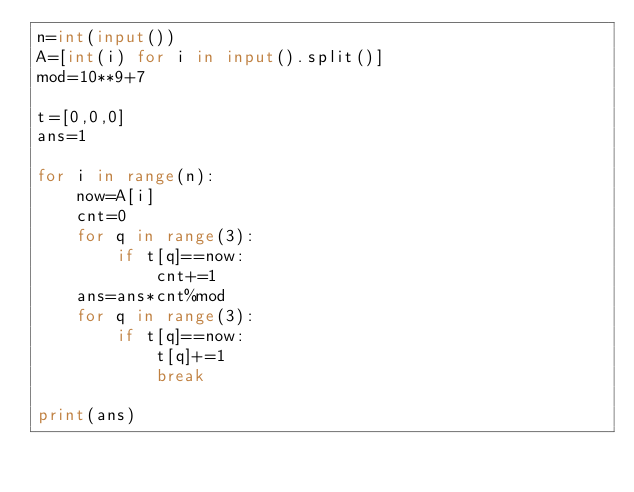Convert code to text. <code><loc_0><loc_0><loc_500><loc_500><_Python_>n=int(input())
A=[int(i) for i in input().split()]
mod=10**9+7

t=[0,0,0]
ans=1

for i in range(n):
    now=A[i]
    cnt=0
    for q in range(3):
        if t[q]==now:
            cnt+=1
    ans=ans*cnt%mod
    for q in range(3):
        if t[q]==now:
            t[q]+=1
            break

print(ans)</code> 